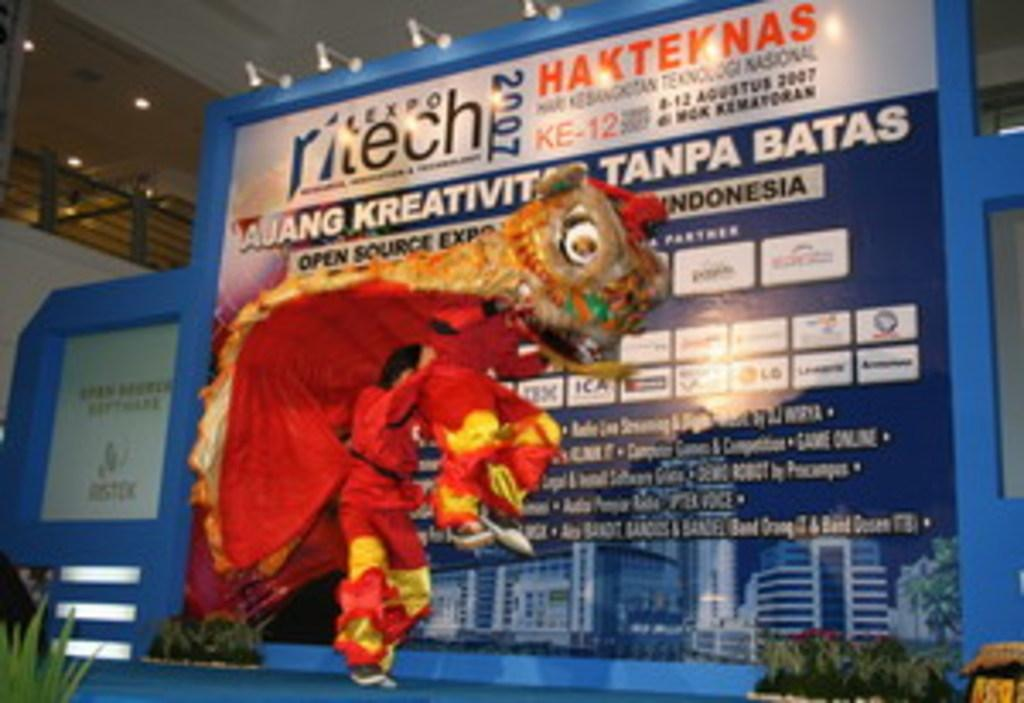How many people are in the image? There are two persons in the image. What are the persons wearing? The persons are wearing dragon dresses. What can be seen in the background of the image? There is a banner in the background of the image, with plants on either side. Where might the image have been taken? The image appears to be taken inside a hall. What type of waste can be seen on the floor in the image? There is no waste visible on the floor in the image. Can you tell me the name of the stranger in the image? There is no stranger present in the image; the two persons are wearing dragon dresses, which suggests they might be part of a group or event. 